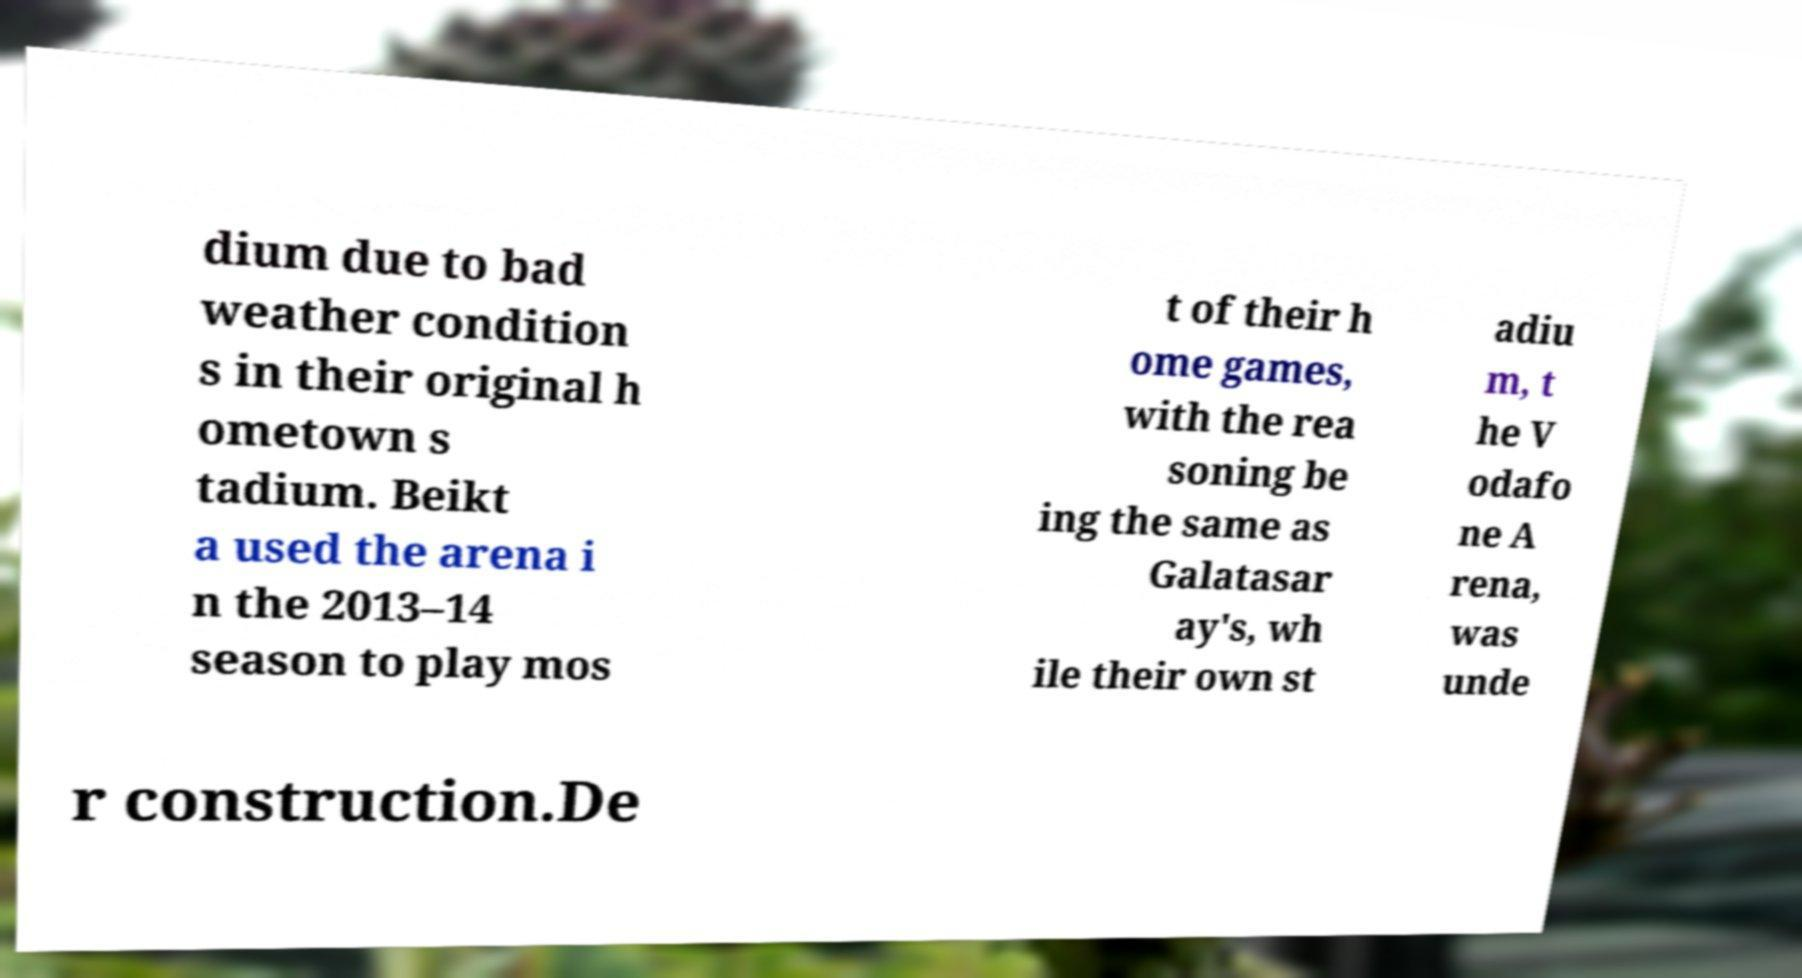Can you accurately transcribe the text from the provided image for me? dium due to bad weather condition s in their original h ometown s tadium. Beikt a used the arena i n the 2013–14 season to play mos t of their h ome games, with the rea soning be ing the same as Galatasar ay's, wh ile their own st adiu m, t he V odafo ne A rena, was unde r construction.De 